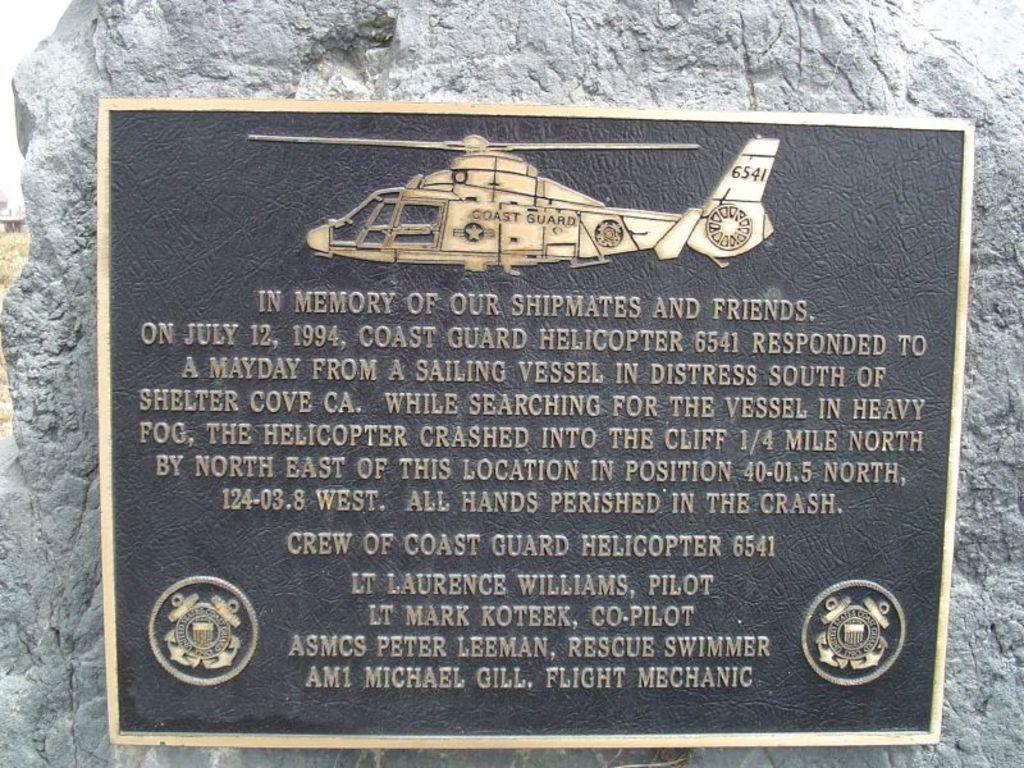Provide a one-sentence caption for the provided image. A plaque in memory of those killed when a coast guard helicopter crashed is hung on a stone. 